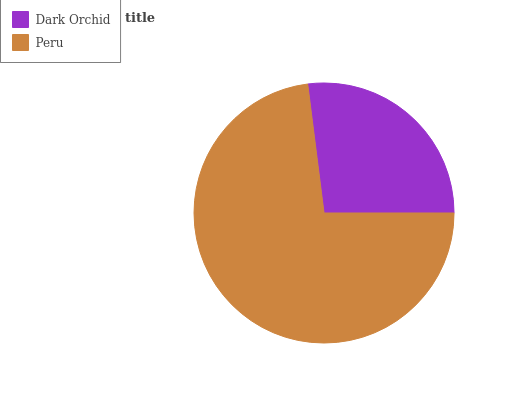Is Dark Orchid the minimum?
Answer yes or no. Yes. Is Peru the maximum?
Answer yes or no. Yes. Is Peru the minimum?
Answer yes or no. No. Is Peru greater than Dark Orchid?
Answer yes or no. Yes. Is Dark Orchid less than Peru?
Answer yes or no. Yes. Is Dark Orchid greater than Peru?
Answer yes or no. No. Is Peru less than Dark Orchid?
Answer yes or no. No. Is Peru the high median?
Answer yes or no. Yes. Is Dark Orchid the low median?
Answer yes or no. Yes. Is Dark Orchid the high median?
Answer yes or no. No. Is Peru the low median?
Answer yes or no. No. 